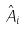Convert formula to latex. <formula><loc_0><loc_0><loc_500><loc_500>\hat { A } _ { i }</formula> 